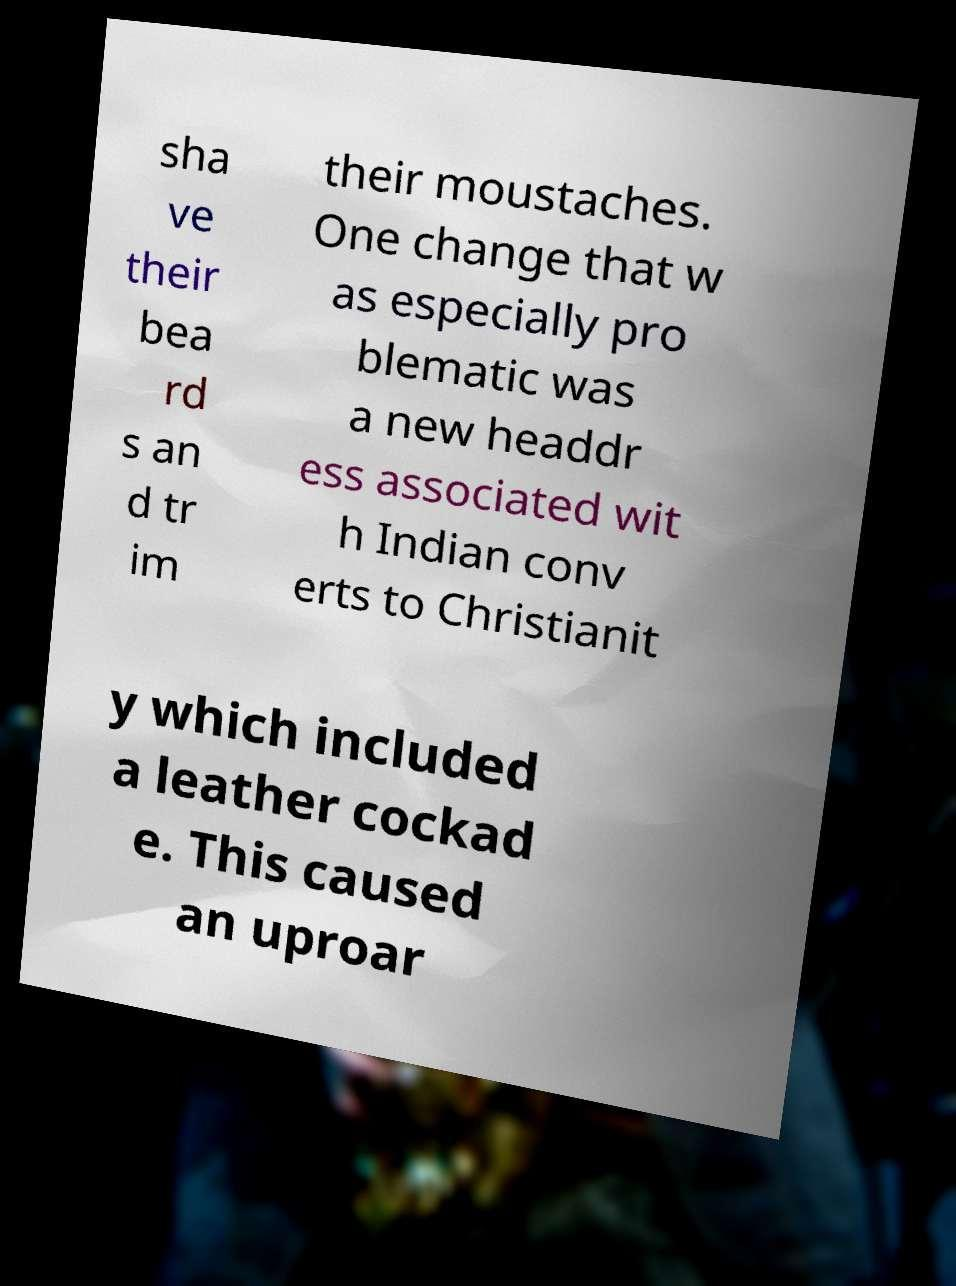Could you assist in decoding the text presented in this image and type it out clearly? sha ve their bea rd s an d tr im their moustaches. One change that w as especially pro blematic was a new headdr ess associated wit h Indian conv erts to Christianit y which included a leather cockad e. This caused an uproar 